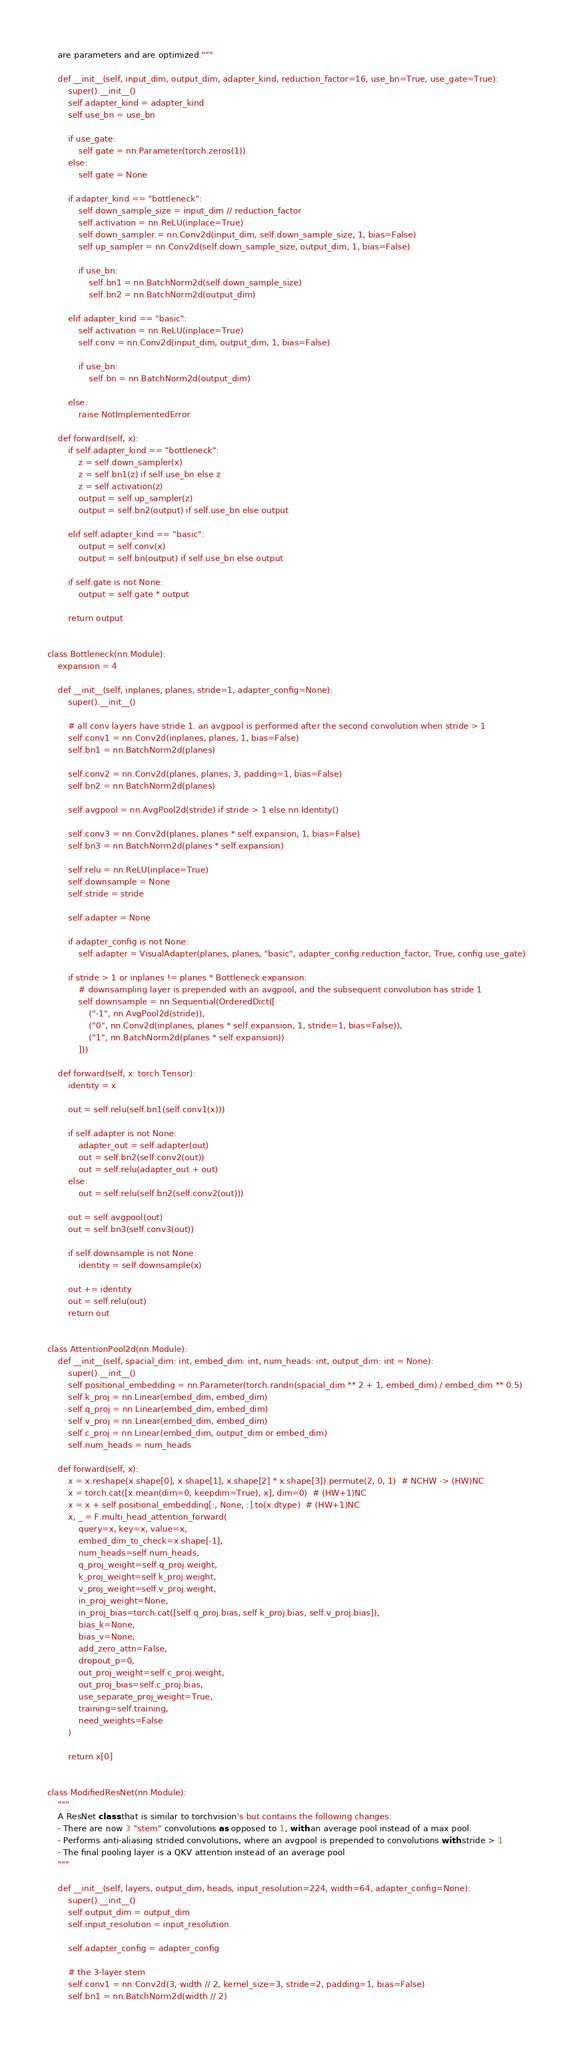<code> <loc_0><loc_0><loc_500><loc_500><_Python_>    are parameters and are optimized."""

    def __init__(self, input_dim, output_dim, adapter_kind, reduction_factor=16, use_bn=True, use_gate=True):
        super().__init__()
        self.adapter_kind = adapter_kind
        self.use_bn = use_bn

        if use_gate:
            self.gate = nn.Parameter(torch.zeros(1))
        else:
            self.gate = None

        if adapter_kind == "bottleneck":
            self.down_sample_size = input_dim // reduction_factor
            self.activation = nn.ReLU(inplace=True)
            self.down_sampler = nn.Conv2d(input_dim, self.down_sample_size, 1, bias=False)
            self.up_sampler = nn.Conv2d(self.down_sample_size, output_dim, 1, bias=False)

            if use_bn:
                self.bn1 = nn.BatchNorm2d(self.down_sample_size)
                self.bn2 = nn.BatchNorm2d(output_dim)

        elif adapter_kind == "basic":
            self.activation = nn.ReLU(inplace=True)
            self.conv = nn.Conv2d(input_dim, output_dim, 1, bias=False)

            if use_bn:
                self.bn = nn.BatchNorm2d(output_dim)

        else:
            raise NotImplementedError

    def forward(self, x):
        if self.adapter_kind == "bottleneck":
            z = self.down_sampler(x)
            z = self.bn1(z) if self.use_bn else z
            z = self.activation(z)
            output = self.up_sampler(z)
            output = self.bn2(output) if self.use_bn else output

        elif self.adapter_kind == "basic":
            output = self.conv(x)
            output = self.bn(output) if self.use_bn else output

        if self.gate is not None:
            output = self.gate * output

        return output


class Bottleneck(nn.Module):
    expansion = 4

    def __init__(self, inplanes, planes, stride=1, adapter_config=None):
        super().__init__()

        # all conv layers have stride 1. an avgpool is performed after the second convolution when stride > 1
        self.conv1 = nn.Conv2d(inplanes, planes, 1, bias=False)
        self.bn1 = nn.BatchNorm2d(planes)

        self.conv2 = nn.Conv2d(planes, planes, 3, padding=1, bias=False)
        self.bn2 = nn.BatchNorm2d(planes)

        self.avgpool = nn.AvgPool2d(stride) if stride > 1 else nn.Identity()

        self.conv3 = nn.Conv2d(planes, planes * self.expansion, 1, bias=False)
        self.bn3 = nn.BatchNorm2d(planes * self.expansion)

        self.relu = nn.ReLU(inplace=True)
        self.downsample = None
        self.stride = stride

        self.adapter = None

        if adapter_config is not None:
            self.adapter = VisualAdapter(planes, planes, "basic", adapter_config.reduction_factor, True, config.use_gate)

        if stride > 1 or inplanes != planes * Bottleneck.expansion:
            # downsampling layer is prepended with an avgpool, and the subsequent convolution has stride 1
            self.downsample = nn.Sequential(OrderedDict([
                ("-1", nn.AvgPool2d(stride)),
                ("0", nn.Conv2d(inplanes, planes * self.expansion, 1, stride=1, bias=False)),
                ("1", nn.BatchNorm2d(planes * self.expansion))
            ]))

    def forward(self, x: torch.Tensor):
        identity = x

        out = self.relu(self.bn1(self.conv1(x)))

        if self.adapter is not None:
            adapter_out = self.adapter(out)
            out = self.bn2(self.conv2(out))
            out = self.relu(adapter_out + out)
        else:
            out = self.relu(self.bn2(self.conv2(out)))

        out = self.avgpool(out)
        out = self.bn3(self.conv3(out))

        if self.downsample is not None:
            identity = self.downsample(x)

        out += identity
        out = self.relu(out)
        return out


class AttentionPool2d(nn.Module):
    def __init__(self, spacial_dim: int, embed_dim: int, num_heads: int, output_dim: int = None):
        super().__init__()
        self.positional_embedding = nn.Parameter(torch.randn(spacial_dim ** 2 + 1, embed_dim) / embed_dim ** 0.5)
        self.k_proj = nn.Linear(embed_dim, embed_dim)
        self.q_proj = nn.Linear(embed_dim, embed_dim)
        self.v_proj = nn.Linear(embed_dim, embed_dim)
        self.c_proj = nn.Linear(embed_dim, output_dim or embed_dim)
        self.num_heads = num_heads

    def forward(self, x):
        x = x.reshape(x.shape[0], x.shape[1], x.shape[2] * x.shape[3]).permute(2, 0, 1)  # NCHW -> (HW)NC
        x = torch.cat([x.mean(dim=0, keepdim=True), x], dim=0)  # (HW+1)NC
        x = x + self.positional_embedding[:, None, :].to(x.dtype)  # (HW+1)NC
        x, _ = F.multi_head_attention_forward(
            query=x, key=x, value=x,
            embed_dim_to_check=x.shape[-1],
            num_heads=self.num_heads,
            q_proj_weight=self.q_proj.weight,
            k_proj_weight=self.k_proj.weight,
            v_proj_weight=self.v_proj.weight,
            in_proj_weight=None,
            in_proj_bias=torch.cat([self.q_proj.bias, self.k_proj.bias, self.v_proj.bias]),
            bias_k=None,
            bias_v=None,
            add_zero_attn=False,
            dropout_p=0,
            out_proj_weight=self.c_proj.weight,
            out_proj_bias=self.c_proj.bias,
            use_separate_proj_weight=True,
            training=self.training,
            need_weights=False
        )

        return x[0]


class ModifiedResNet(nn.Module):
    """
    A ResNet class that is similar to torchvision's but contains the following changes:
    - There are now 3 "stem" convolutions as opposed to 1, with an average pool instead of a max pool.
    - Performs anti-aliasing strided convolutions, where an avgpool is prepended to convolutions with stride > 1
    - The final pooling layer is a QKV attention instead of an average pool
    """

    def __init__(self, layers, output_dim, heads, input_resolution=224, width=64, adapter_config=None):
        super().__init__()
        self.output_dim = output_dim
        self.input_resolution = input_resolution

        self.adapter_config = adapter_config

        # the 3-layer stem
        self.conv1 = nn.Conv2d(3, width // 2, kernel_size=3, stride=2, padding=1, bias=False)
        self.bn1 = nn.BatchNorm2d(width // 2)</code> 